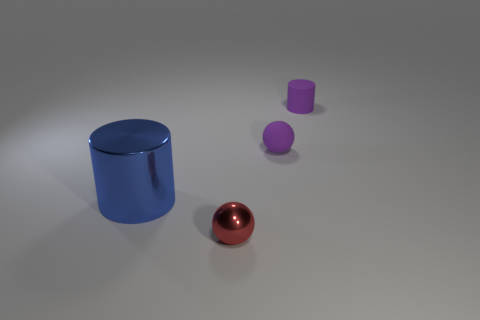The tiny shiny object has what shape?
Keep it short and to the point. Sphere. How many objects are either tiny brown spheres or blue cylinders?
Provide a succinct answer. 1. There is a matte object left of the tiny cylinder; is its size the same as the cylinder to the right of the red ball?
Your response must be concise. Yes. How many other things are the same material as the purple cylinder?
Your answer should be very brief. 1. Are there more tiny red objects that are behind the purple rubber sphere than large metal things that are in front of the red shiny sphere?
Your answer should be compact. No. There is a purple thing on the right side of the small purple matte sphere; what material is it?
Keep it short and to the point. Rubber. Does the big blue shiny object have the same shape as the small red object?
Your answer should be very brief. No. Are there any other things that are the same color as the tiny metallic sphere?
Your answer should be very brief. No. There is a small object that is the same shape as the big metal thing; what color is it?
Keep it short and to the point. Purple. Are there more purple matte objects left of the purple matte cylinder than tiny objects?
Provide a succinct answer. No. 